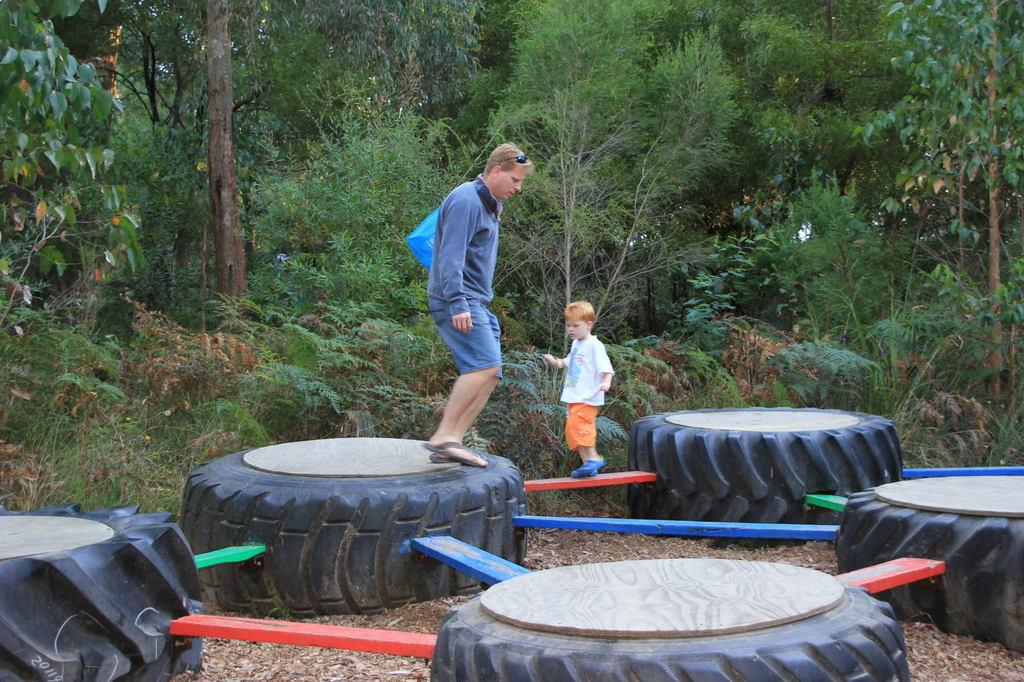What objects can be seen in the image? There are tyres in the image. How many people are present in the image? There are two persons standing in the image. Can you describe the clothing of the two persons? One person is wearing a blue color jacket, and the other person is wearing a white color t-shirt. What type of vegetation can be seen in the image? There are plants and trees in the image. What theory is the person wearing the blue jacket discussing with the person in the white t-shirt? There is no indication in the image that the two persons are discussing any theories. --- Facts: 1. There is a car in the image. 2. The car is parked on the side of the road. 3. There are trees in the background of the image. 4. The sky is visible in the image. 5. There is a person standing near the car. Absurd Topics: dance, ocean, birdhouse Conversation: What vehicle is present in the image? There is a car in the image. Where is the car located in the image? The car is parked on the side of the road. What can be seen in the background of the image? There are trees in the background of the image. What is visible at the top of the image? The sky is visible in the image. Is there anyone near the car in the image? Yes, there is a person standing near the car. Reasoning: Let's think step by step in order to produce the conversation. We start by identifying the main subject in the image, which is the car. Then, we describe the car's location and the surrounding environment, including the trees and sky. Finally, we mention the presence of a person near the car. Absurd Question/Answer: Can you see any birdhouses in the image? There is no birdhouse present in the image. Is the person near the car dancing in the image? There is no indication in the image that the person is dancing. --- Facts: 1. There is a table in the image. 2. There are books on the table. 3. There is a lamp on the table. 4. There is a chair next to the table. 5. The room has a wooden floor. Absurd Topics: elephant, ocean, bicycle Conversation: What piece of furniture is present in the image? There is a table in the image. What items can be seen on the table? There are books and a lamp on the table. Is there any seating arrangement near the table? Yes, there is a chair next to the table. What type of flooring is present in the room? The room has a wooden floor. Reasoning: Let's think step by step in order to produce the conversation. We start by identifying the main piece of furniture in the image 